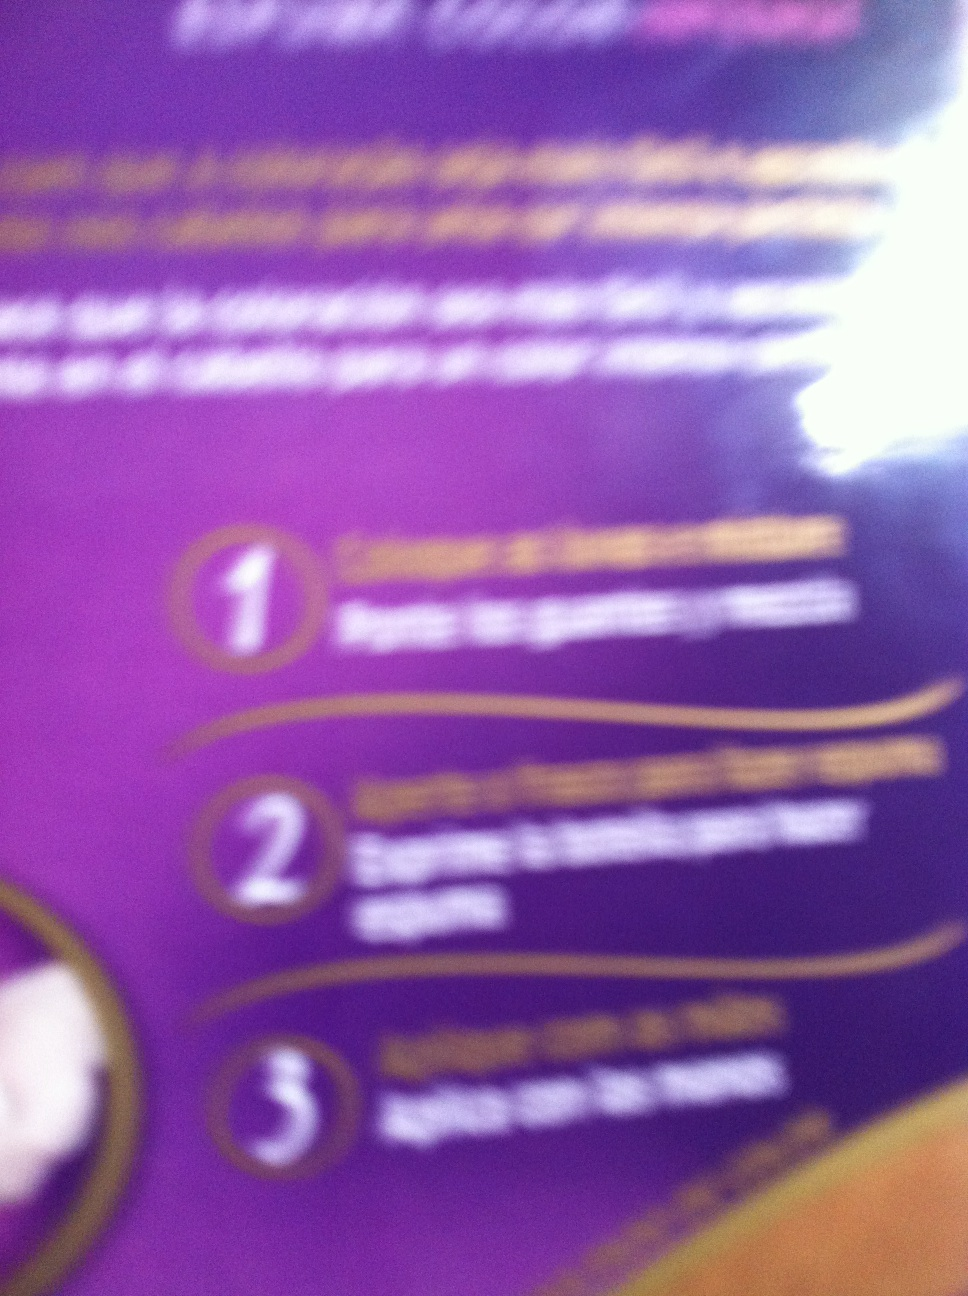In a realistic scenario, how would a busy professional incorporate this product into their daily routine? A busy professional might incorporate this product into their daily routine by applying it in the morning after a shower. They would quickly apply the product, ensuring it is evenly spread and take a moment to let it absorb while they prepare for their day. They might also keep a small amount at their desk for midday touch-ups to maintain hydration and protection throughout the day. 